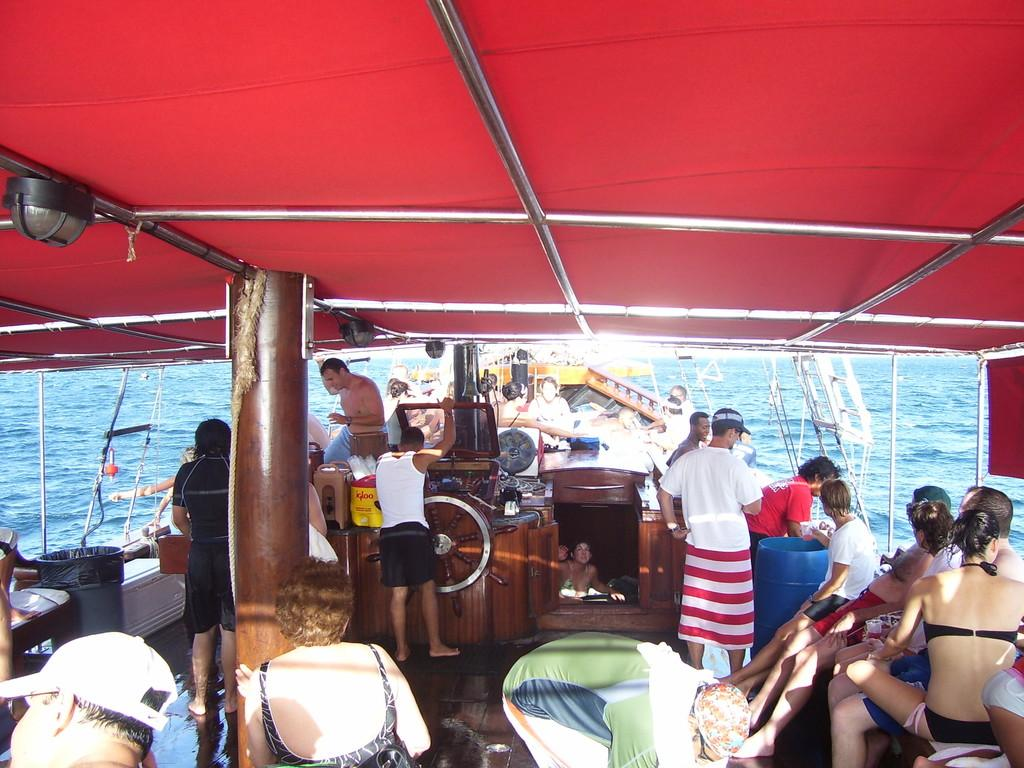How many people are in the image? There are many persons in the image. What are the persons doing in the image? The persons are sailing in a boat. What can be seen at the bottom of the image? There is water visible at the bottom of the image. What color is the roof of the boat? The roof of the boat is in red color. What type of eggnog is being served on the wrist of the person in the image? There is no eggnog or wrist visible in the image; it features many persons sailing in a boat. What kind of thing is being held by the person in the image? The provided facts do not mention any specific thing being held by a person in the image. 